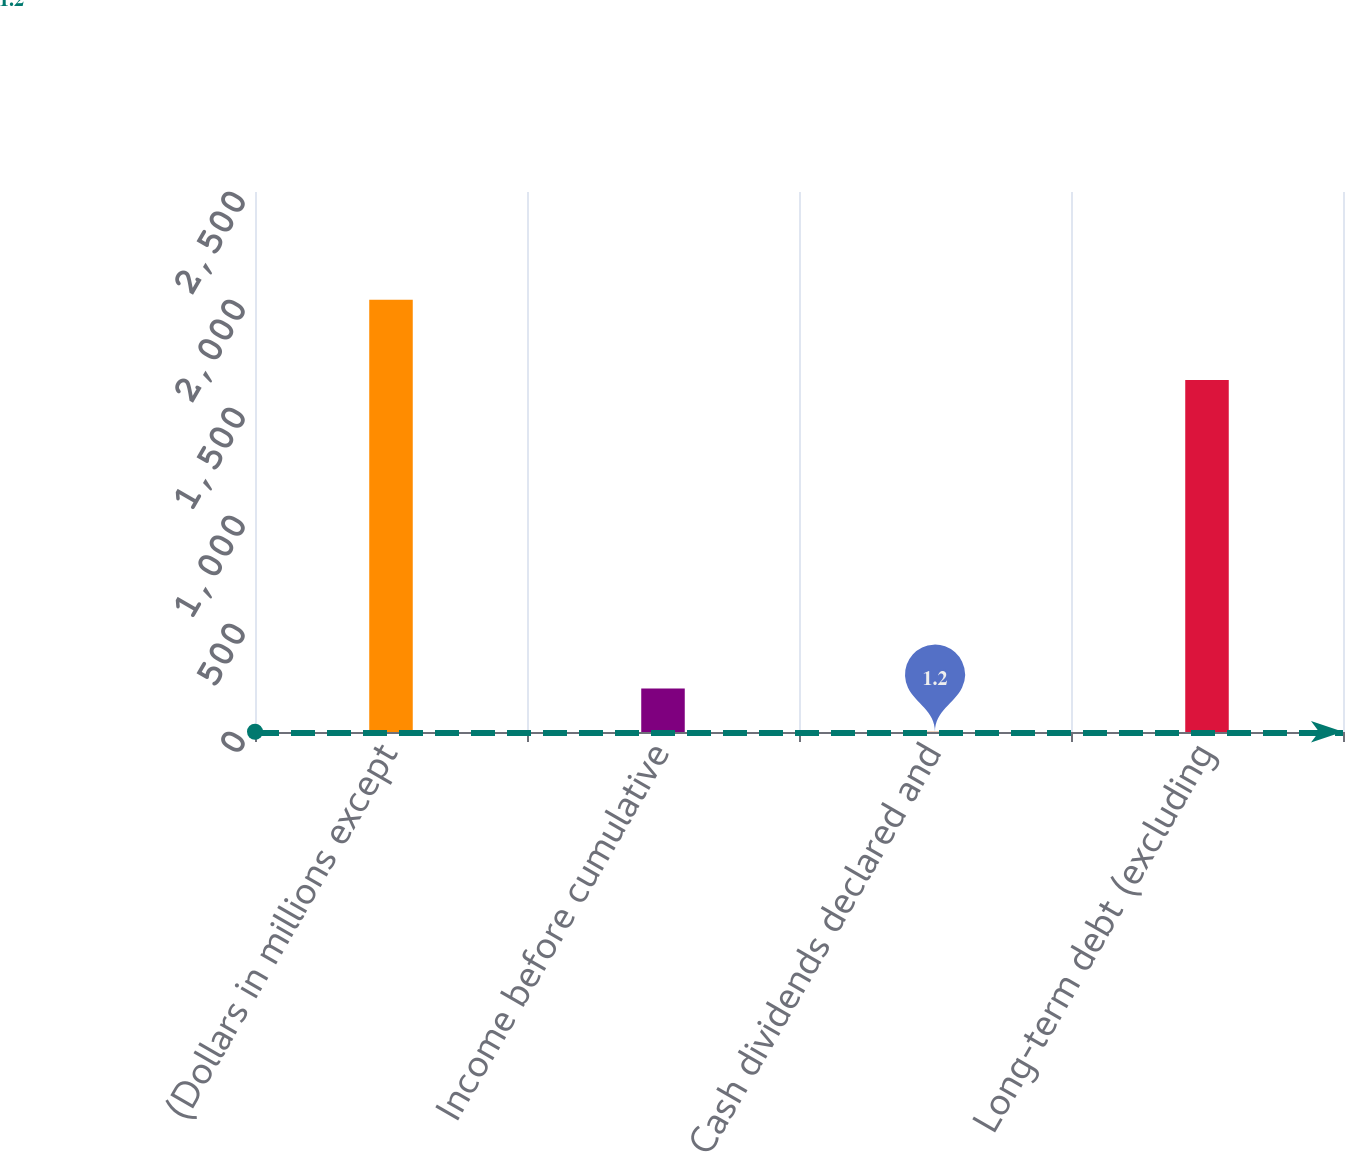Convert chart to OTSL. <chart><loc_0><loc_0><loc_500><loc_500><bar_chart><fcel>(Dollars in millions except<fcel>Income before cumulative<fcel>Cash dividends declared and<fcel>Long-term debt (excluding<nl><fcel>2001<fcel>201.18<fcel>1.2<fcel>1629.98<nl></chart> 